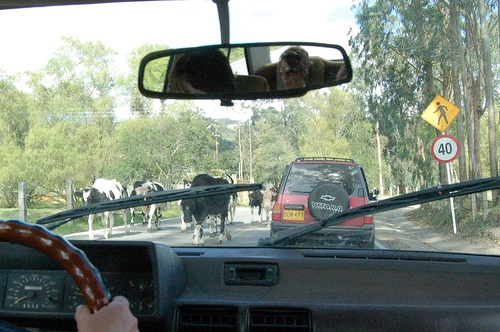Describe the objects in this image and their specific colors. I can see car in black, white, darkgray, gray, and beige tones, car in black, gray, darkgray, and purple tones, people in black and gray tones, cow in black, purple, gray, and darkgray tones, and cow in black, white, gray, darkgray, and lightgray tones in this image. 